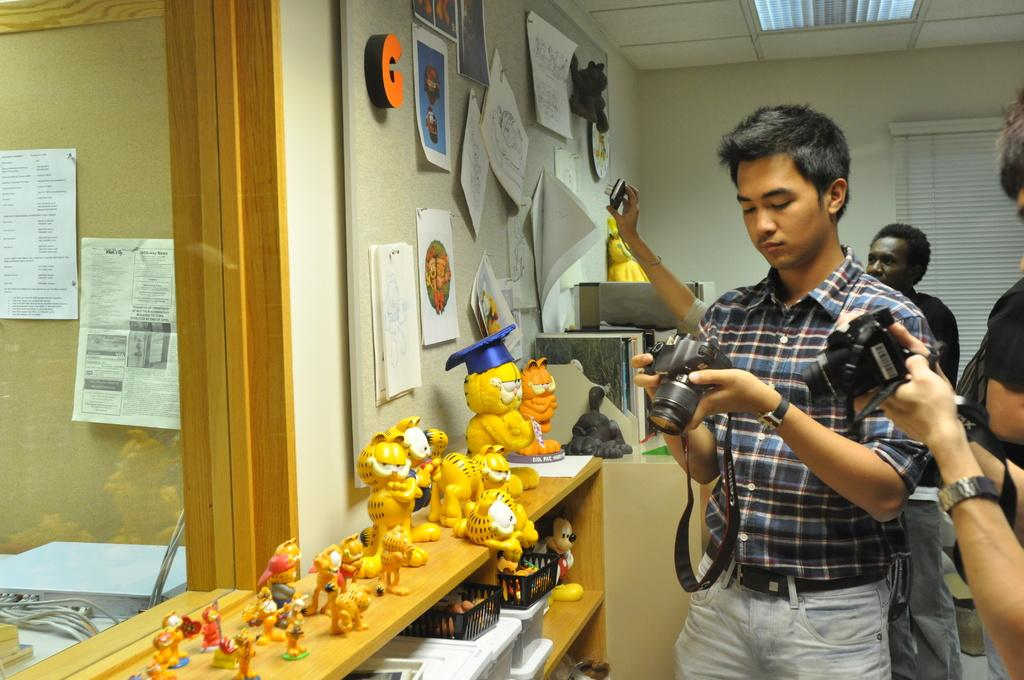<image>
Share a concise interpretation of the image provided. A group of photographers adjust their equipment near a bulletin board with an orange letter G pinned to it. 